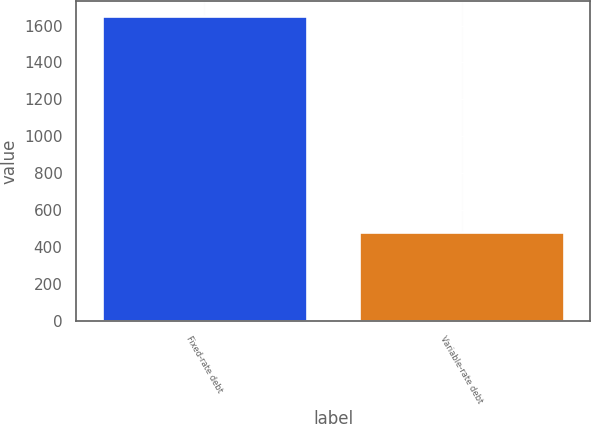Convert chart. <chart><loc_0><loc_0><loc_500><loc_500><bar_chart><fcel>Fixed-rate debt<fcel>Variable-rate debt<nl><fcel>1651<fcel>483<nl></chart> 